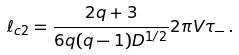Convert formula to latex. <formula><loc_0><loc_0><loc_500><loc_500>\ell _ { c 2 } = \frac { 2 q + 3 } { 6 q ( q - 1 ) D ^ { 1 / 2 } } 2 \pi V \tau _ { - } \, .</formula> 